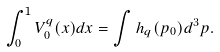Convert formula to latex. <formula><loc_0><loc_0><loc_500><loc_500>\int _ { 0 } ^ { 1 } V _ { 0 } ^ { q } ( x ) d x = \int h _ { q } ( p _ { 0 } ) d ^ { 3 } p .</formula> 